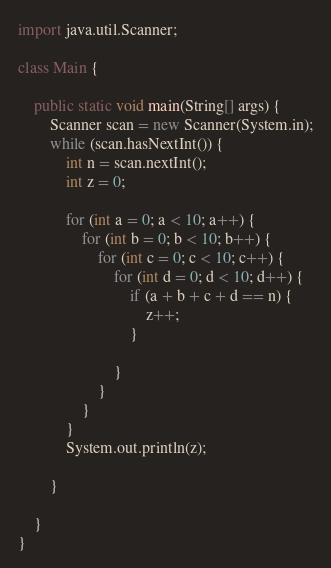Convert code to text. <code><loc_0><loc_0><loc_500><loc_500><_Java_>import java.util.Scanner;

class Main {

    public static void main(String[] args) {
        Scanner scan = new Scanner(System.in);
        while (scan.hasNextInt()) {
            int n = scan.nextInt();
            int z = 0;

            for (int a = 0; a < 10; a++) {
                for (int b = 0; b < 10; b++) {
                    for (int c = 0; c < 10; c++) {
                        for (int d = 0; d < 10; d++) {
                            if (a + b + c + d == n) {
                                z++;
                            }

                        }
                    }
                }
            }
            System.out.println(z);

        }

    }
}

</code> 